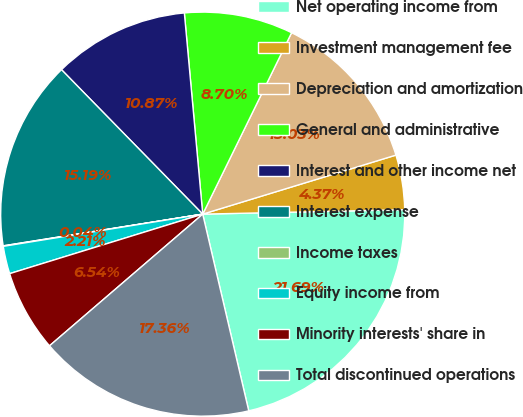Convert chart. <chart><loc_0><loc_0><loc_500><loc_500><pie_chart><fcel>Net operating income from<fcel>Investment management fee<fcel>Depreciation and amortization<fcel>General and administrative<fcel>Interest and other income net<fcel>Interest expense<fcel>Income taxes<fcel>Equity income from<fcel>Minority interests' share in<fcel>Total discontinued operations<nl><fcel>21.69%<fcel>4.37%<fcel>13.03%<fcel>8.7%<fcel>10.87%<fcel>15.19%<fcel>0.04%<fcel>2.21%<fcel>6.54%<fcel>17.36%<nl></chart> 